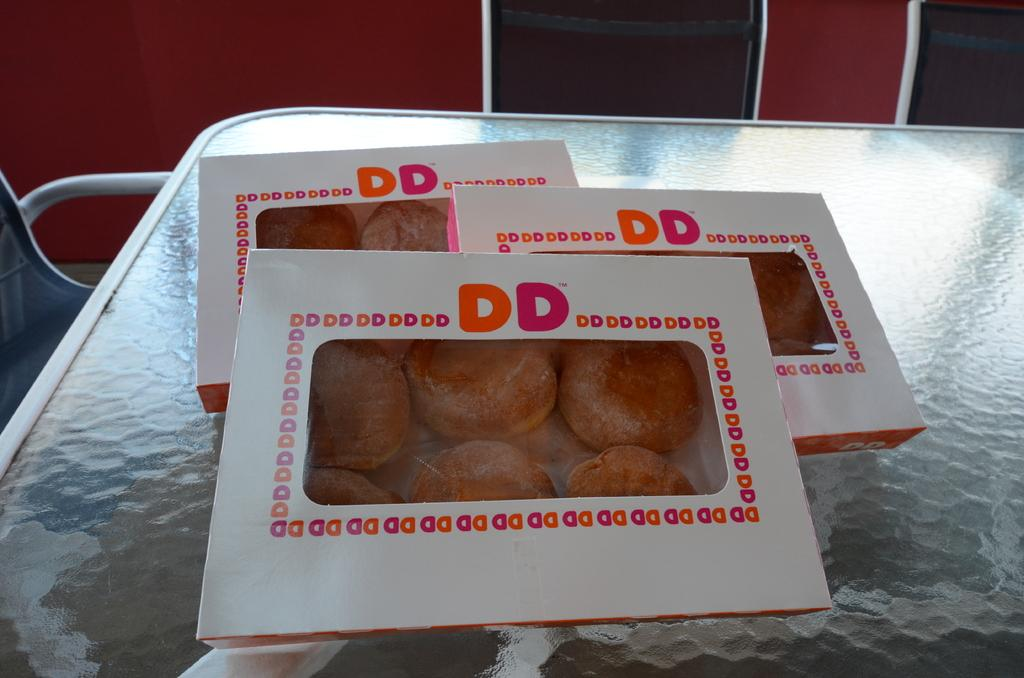What type of objects are in the image? There are food items in the image. How are the food items contained? The food items are in boxes. Where are the boxes located? The boxes are on a table. Is there any furniture in the image? Yes, there is a chair in the image. How many mint leaves are on the table in the image? There is no mention of mint leaves in the image, so we cannot determine their presence or quantity. 